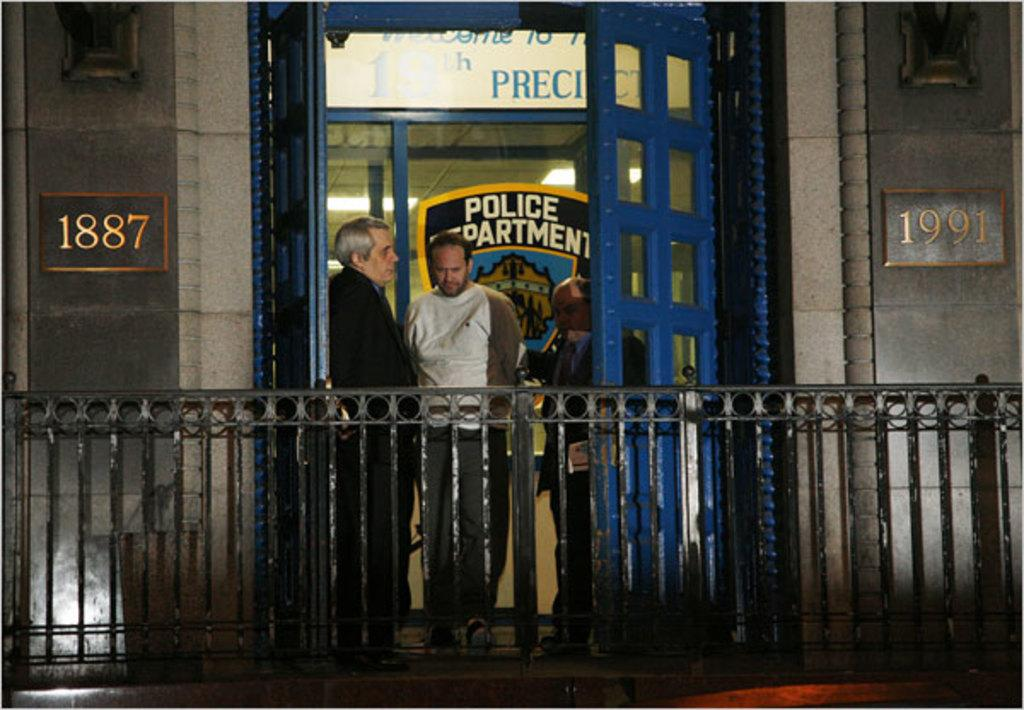How many people are present in the image? There are three persons standing in the image. What type of structure can be seen in the image? There are iron grilles in the image. What other objects are visible in the image? There are boards in the image. What can be seen in the background of the image? There is a building in the background of the image. Where is the shelf located in the image? There is no shelf present in the image. How does the fold in the iron grille affect the appearance of the image? There is no fold in the iron grille mentioned in the image, so it cannot affect the appearance. 